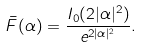Convert formula to latex. <formula><loc_0><loc_0><loc_500><loc_500>\bar { F } ( \alpha ) = \frac { I _ { 0 } ( 2 | \alpha | ^ { 2 } ) } { e ^ { 2 | \alpha | ^ { 2 } } } .</formula> 